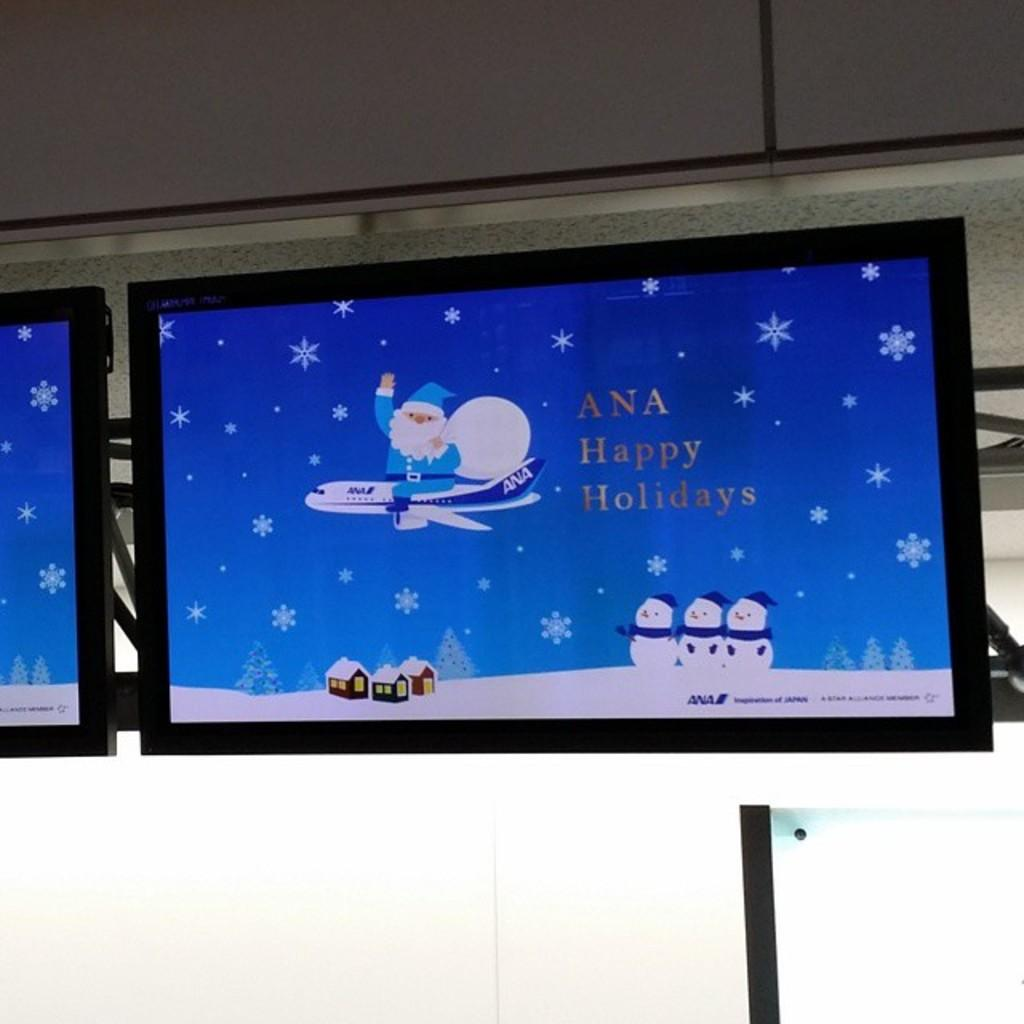<image>
Create a compact narrative representing the image presented. A holidays message to Ana is displayed on a video screen. 